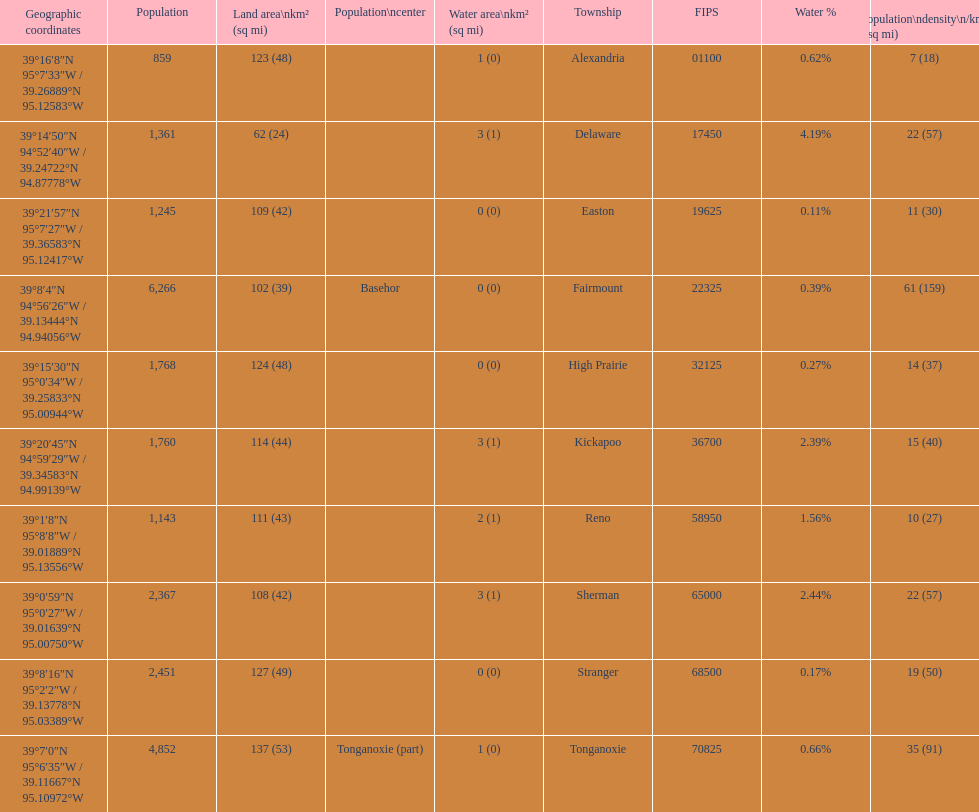What is the number of townships with a population larger than 2,000? 4. 